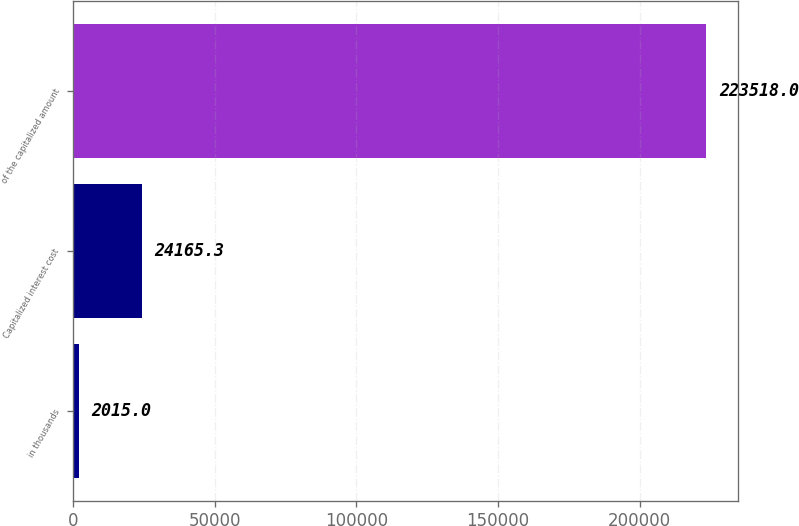Convert chart. <chart><loc_0><loc_0><loc_500><loc_500><bar_chart><fcel>in thousands<fcel>Capitalized interest cost<fcel>of the capitalized amount<nl><fcel>2015<fcel>24165.3<fcel>223518<nl></chart> 